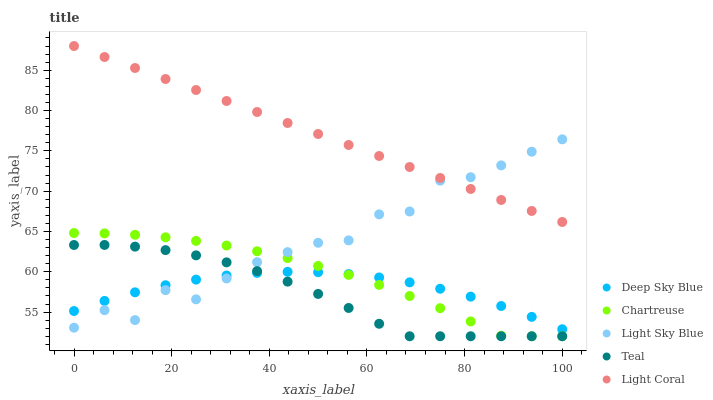Does Teal have the minimum area under the curve?
Answer yes or no. Yes. Does Light Coral have the maximum area under the curve?
Answer yes or no. Yes. Does Chartreuse have the minimum area under the curve?
Answer yes or no. No. Does Chartreuse have the maximum area under the curve?
Answer yes or no. No. Is Light Coral the smoothest?
Answer yes or no. Yes. Is Light Sky Blue the roughest?
Answer yes or no. Yes. Is Chartreuse the smoothest?
Answer yes or no. No. Is Chartreuse the roughest?
Answer yes or no. No. Does Chartreuse have the lowest value?
Answer yes or no. Yes. Does Light Sky Blue have the lowest value?
Answer yes or no. No. Does Light Coral have the highest value?
Answer yes or no. Yes. Does Chartreuse have the highest value?
Answer yes or no. No. Is Chartreuse less than Light Coral?
Answer yes or no. Yes. Is Light Coral greater than Chartreuse?
Answer yes or no. Yes. Does Teal intersect Light Sky Blue?
Answer yes or no. Yes. Is Teal less than Light Sky Blue?
Answer yes or no. No. Is Teal greater than Light Sky Blue?
Answer yes or no. No. Does Chartreuse intersect Light Coral?
Answer yes or no. No. 